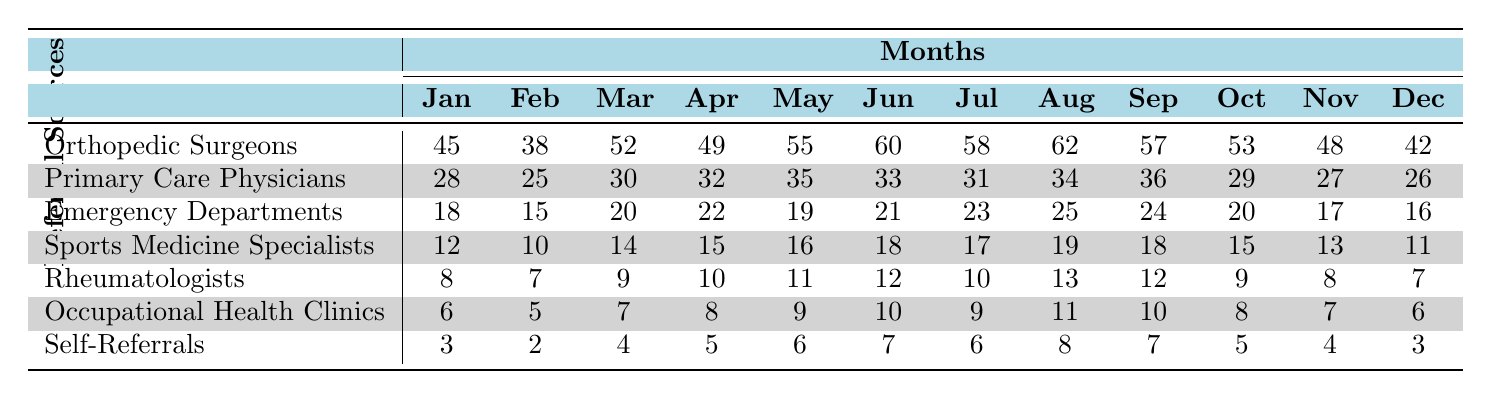What is the total number of referrals from Orthopedic Surgeons in December? The data shows that in December, the number of referrals from Orthopedic Surgeons is 42.
Answer: 42 Which referral source had the least number of referrals in June? In June, Self-Referrals had 7 referrals, which is less than all other sources listed.
Answer: Self-Referrals What was the average number of referrals from Emergency Departments over the year? The total referrals from Emergency Departments is (18 + 15 + 20 + 22 + 19 + 21 + 23 + 25 + 24 + 20 + 17 + 16) =  280. Dividing by 12 months gives an average of 280 / 12 = 23.33.
Answer: 23.33 Which month had the highest total referrals from all sources combined? To find the month with the highest total, sum the referrals for each month across all sources. January has the highest total of (45 + 28 + 18 + 12 + 8 + 6 + 3) = 120.
Answer: January Is there a month where all the referral sources had more than 20 referrals? Looking through the data, no month has all sources exceeding 20 referrals; for instance, the lowest for June is Self-Referrals at 9.
Answer: No What was the percentage increase in referrals from Sports Medicine Specialists from January to June? In January, there were 12 referrals. In June, there were 18 referrals. The increase is (18 - 12) / 12 * 100% = 50%.
Answer: 50% How do the total referrals from Primary Care Physicians compare to those from Occupational Health Clinics across all months? Summing for Primary Care Physicians gives 28 + 25 + 30 + 32 + 35 + 33 + 31 + 34 + 36 + 29 + 27 + 26 =  378. For Occupational Health Clinics, it’s 6 + 5 + 7 + 8 + 9 + 10 + 9 + 11 + 10 + 8 + 7 + 6 =  88. The difference is 378 - 88 = 290.
Answer: 290 During which month did Rheumatologists have their highest referrals? The highest number for Rheumatologists occurred in May with 11 referrals.
Answer: May What is the total referral count for Self-Referrals across the year? Summing up the Self-Referrals gives (3 + 2 + 4 + 5 + 6 + 7 + 6 + 8 + 7 + 5 + 4 + 3) = 60.
Answer: 60 Which referral source had the highest overall referrals for the year? Adding referrals overall: Orthopedic Surgeons total is 675, Primary Care Physicians total is  360, Emergency Departments total is  280, Sports Medicine is  175, Rheumatologists is  115, Occupational Health Clinics is  85, and Self-Referrals is  60. Orthopedic Surgeons had the highest total of 675.
Answer: Orthopedic Surgeons 